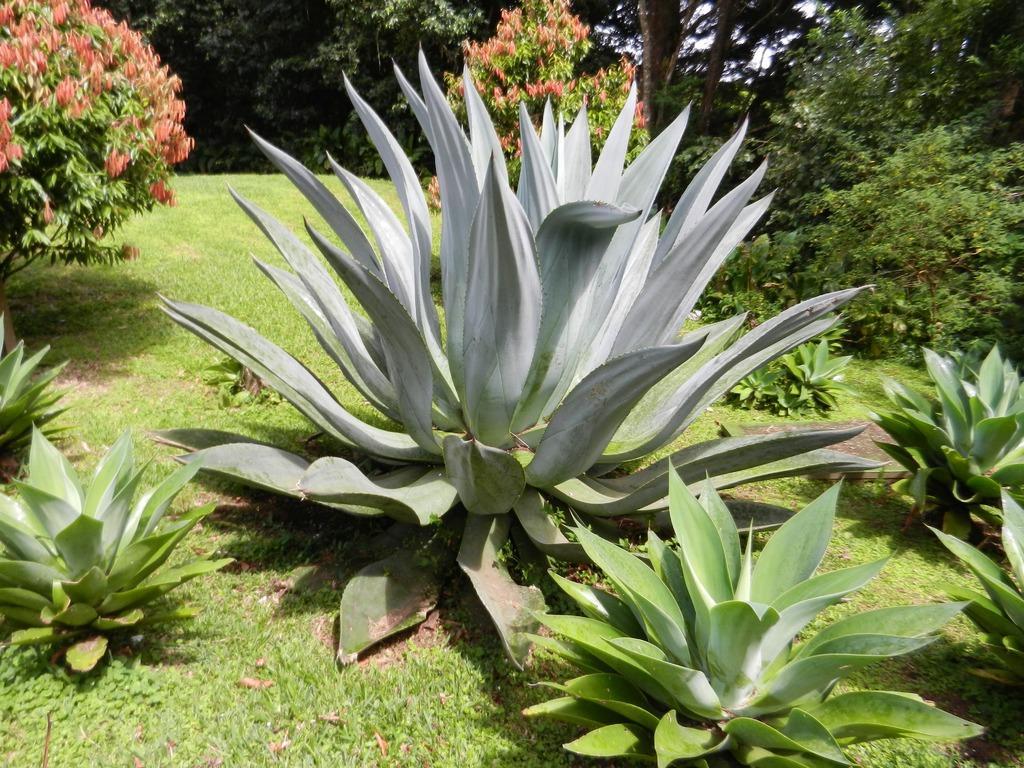In one or two sentences, can you explain what this image depicts? At the bottom of this image, there are plants and grass on the ground. In the background, there are trees, plants and grass on the ground and there is sky. 